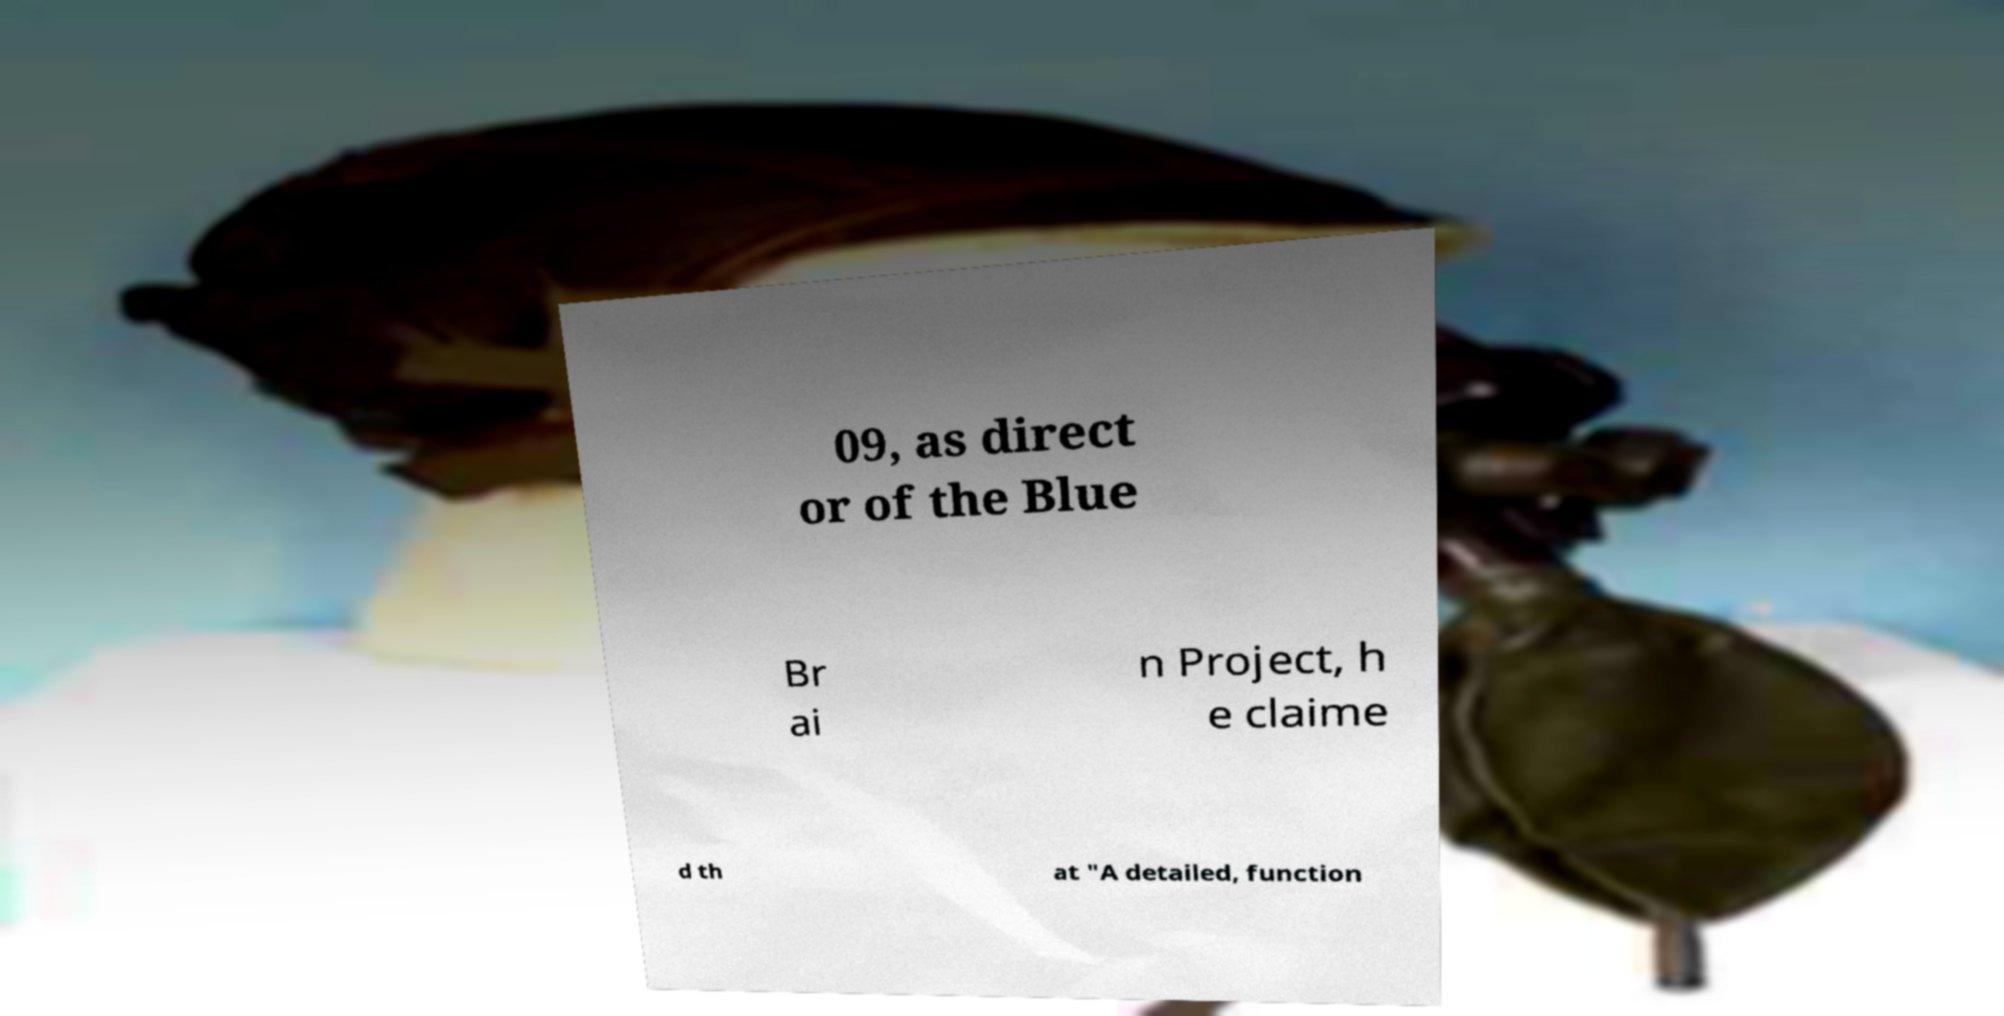For documentation purposes, I need the text within this image transcribed. Could you provide that? 09, as direct or of the Blue Br ai n Project, h e claime d th at "A detailed, function 